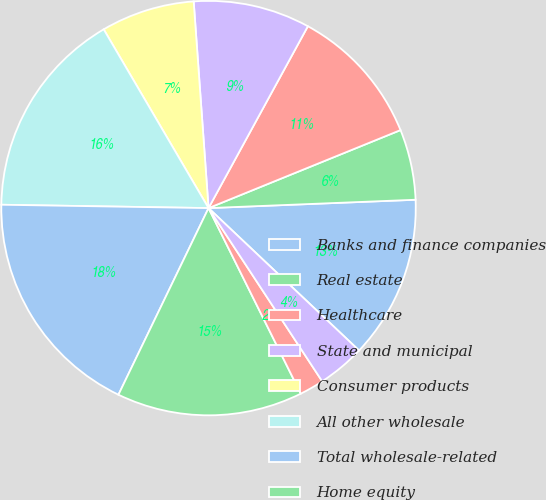Convert chart to OTSL. <chart><loc_0><loc_0><loc_500><loc_500><pie_chart><fcel>Banks and finance companies<fcel>Real estate<fcel>Healthcare<fcel>State and municipal<fcel>Consumer products<fcel>All other wholesale<fcel>Total wholesale-related<fcel>Home equity<fcel>Mortgage<fcel>Auto loans and leases<nl><fcel>12.7%<fcel>5.5%<fcel>10.9%<fcel>9.1%<fcel>7.3%<fcel>16.3%<fcel>18.1%<fcel>14.5%<fcel>1.9%<fcel>3.7%<nl></chart> 